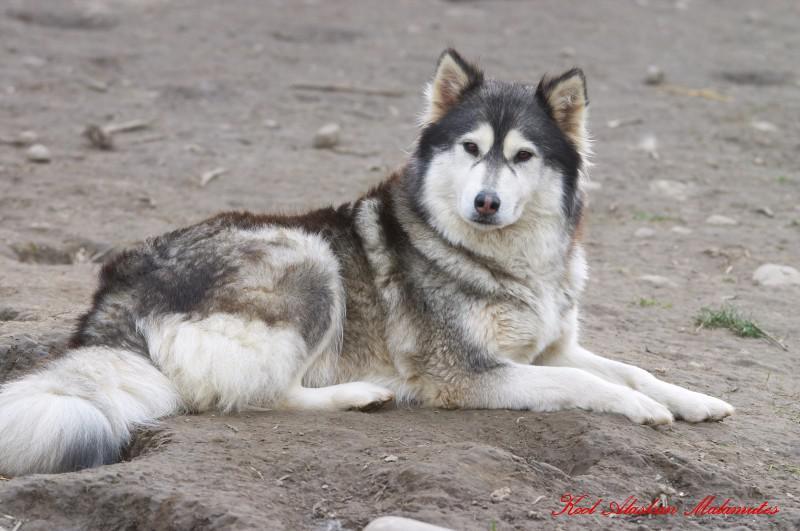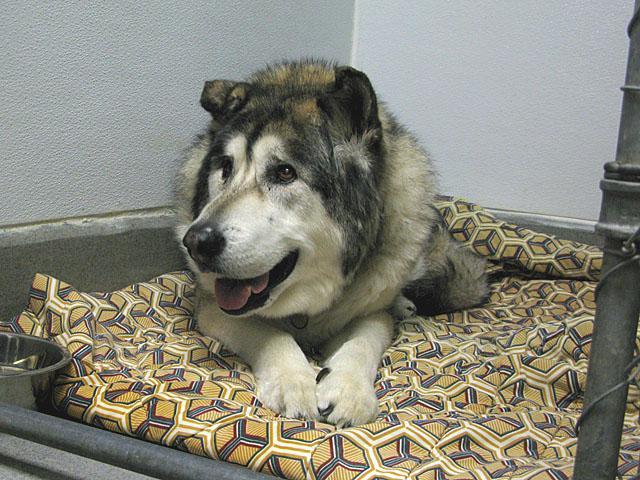The first image is the image on the left, the second image is the image on the right. For the images shown, is this caption "The left image includes a husky reclining with its head to the right, and the right image includes a husky reclining with front paws forward." true? Answer yes or no. Yes. The first image is the image on the left, the second image is the image on the right. Given the left and right images, does the statement "A mom dog is with at least one puppy." hold true? Answer yes or no. No. 